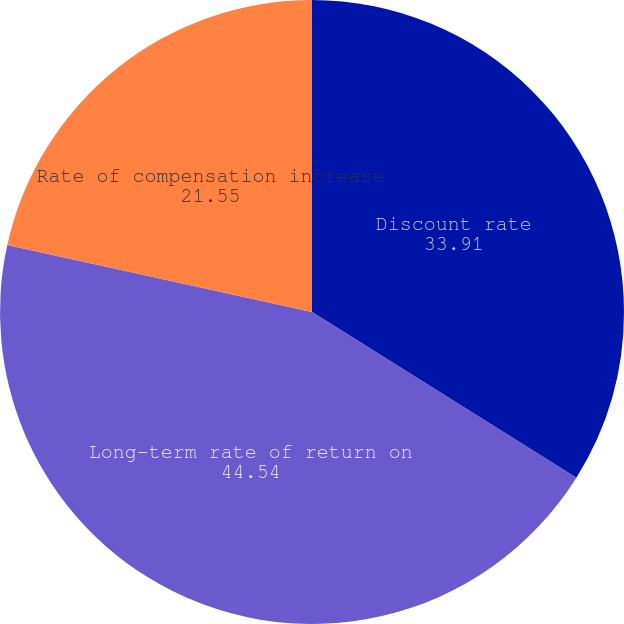Convert chart to OTSL. <chart><loc_0><loc_0><loc_500><loc_500><pie_chart><fcel>Discount rate<fcel>Long-term rate of return on<fcel>Rate of compensation increase<nl><fcel>33.91%<fcel>44.54%<fcel>21.55%<nl></chart> 